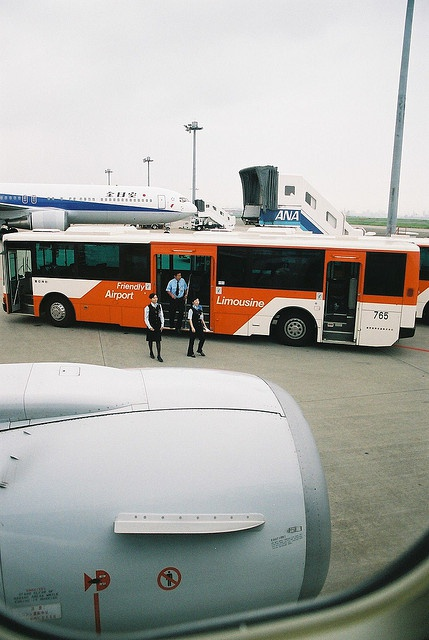Describe the objects in this image and their specific colors. I can see airplane in lightgray, teal, and darkgray tones, bus in lightgray, black, red, and brown tones, airplane in lightgray, white, darkgray, gray, and blue tones, people in lightgray, black, darkgray, and gray tones, and people in lightgray, black, lightblue, and gray tones in this image. 